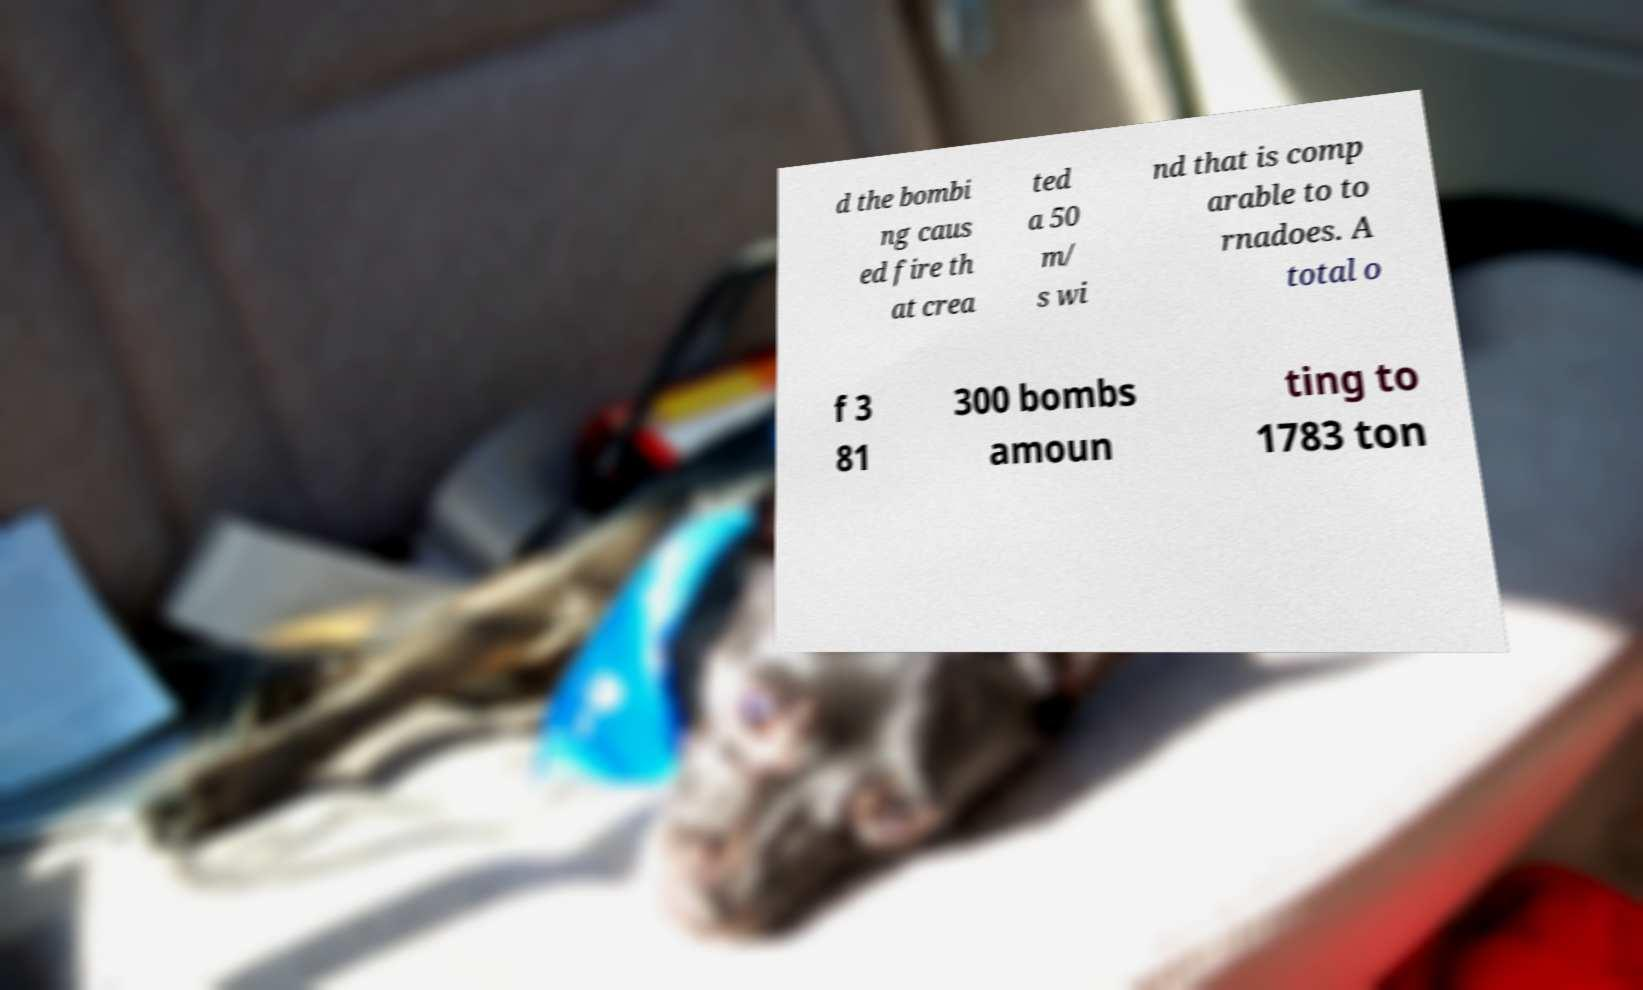What messages or text are displayed in this image? I need them in a readable, typed format. d the bombi ng caus ed fire th at crea ted a 50 m/ s wi nd that is comp arable to to rnadoes. A total o f 3 81 300 bombs amoun ting to 1783 ton 